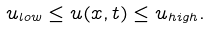<formula> <loc_0><loc_0><loc_500><loc_500>u _ { l o w } \leq u ( x , t ) \leq u _ { h i g h } .</formula> 